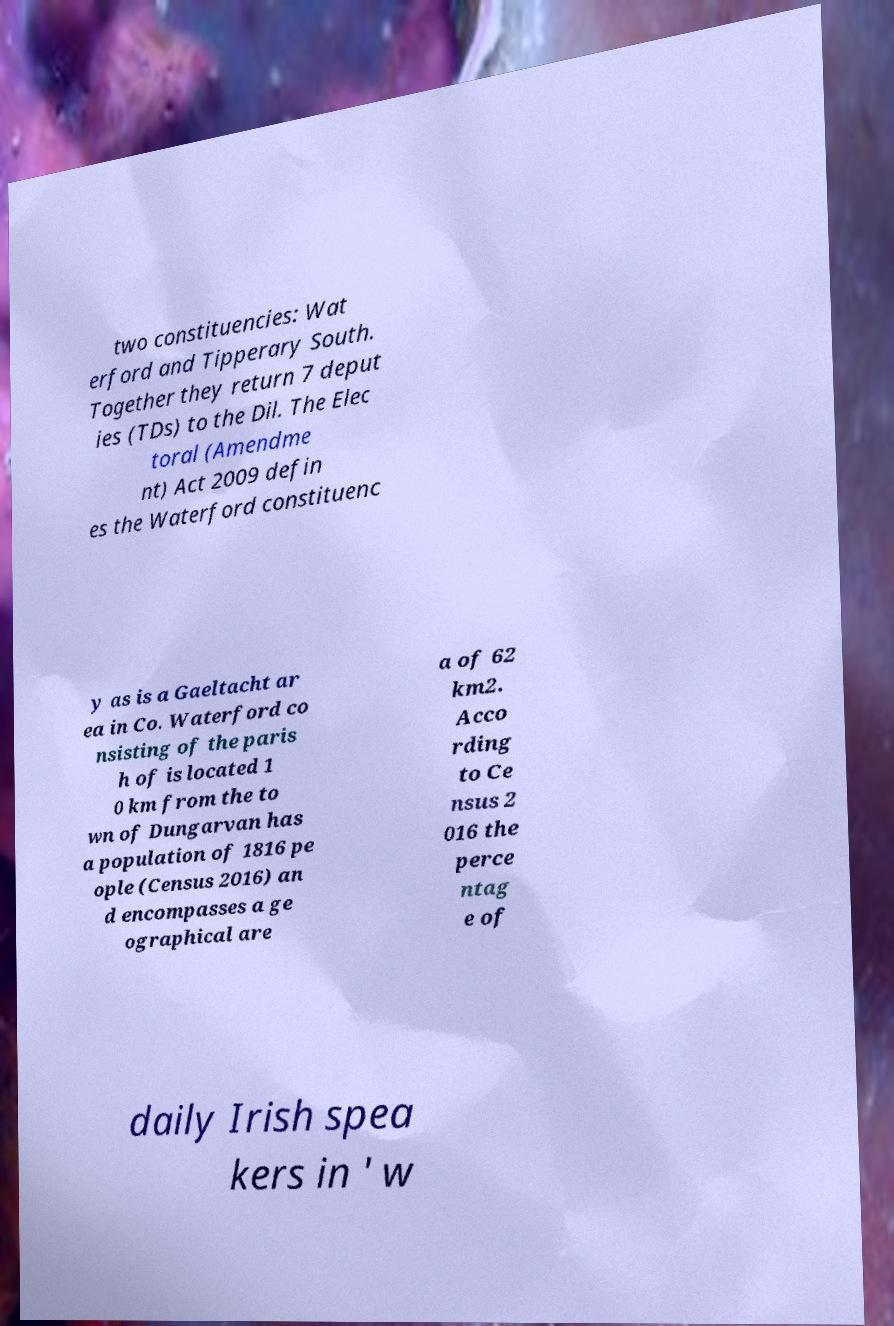For documentation purposes, I need the text within this image transcribed. Could you provide that? two constituencies: Wat erford and Tipperary South. Together they return 7 deput ies (TDs) to the Dil. The Elec toral (Amendme nt) Act 2009 defin es the Waterford constituenc y as is a Gaeltacht ar ea in Co. Waterford co nsisting of the paris h of is located 1 0 km from the to wn of Dungarvan has a population of 1816 pe ople (Census 2016) an d encompasses a ge ographical are a of 62 km2. Acco rding to Ce nsus 2 016 the perce ntag e of daily Irish spea kers in ' w 